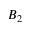<formula> <loc_0><loc_0><loc_500><loc_500>B _ { 2 }</formula> 